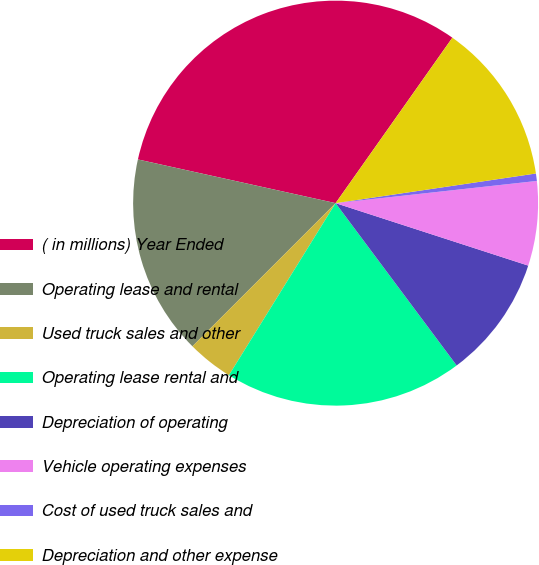<chart> <loc_0><loc_0><loc_500><loc_500><pie_chart><fcel>( in millions) Year Ended<fcel>Operating lease and rental<fcel>Used truck sales and other<fcel>Operating lease rental and<fcel>Depreciation of operating<fcel>Vehicle operating expenses<fcel>Cost of used truck sales and<fcel>Depreciation and other expense<nl><fcel>31.32%<fcel>15.96%<fcel>3.67%<fcel>19.03%<fcel>9.81%<fcel>6.74%<fcel>0.59%<fcel>12.88%<nl></chart> 